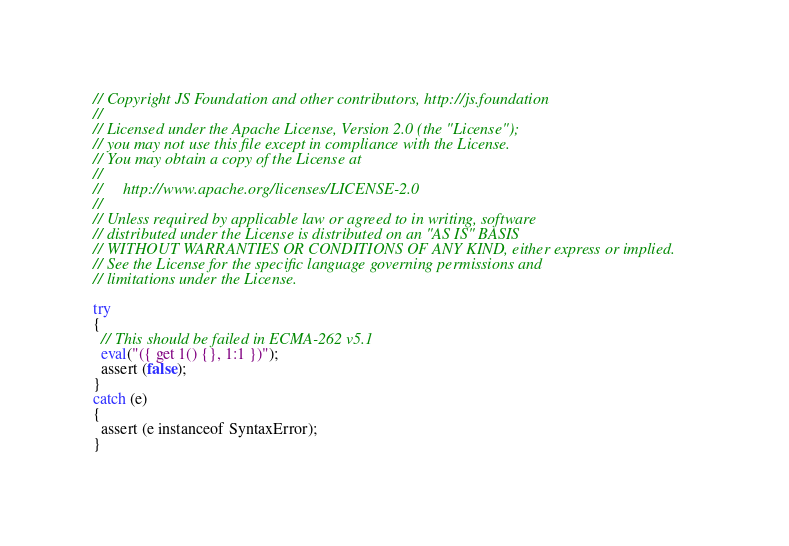Convert code to text. <code><loc_0><loc_0><loc_500><loc_500><_JavaScript_>// Copyright JS Foundation and other contributors, http://js.foundation
//
// Licensed under the Apache License, Version 2.0 (the "License");
// you may not use this file except in compliance with the License.
// You may obtain a copy of the License at
//
//     http://www.apache.org/licenses/LICENSE-2.0
//
// Unless required by applicable law or agreed to in writing, software
// distributed under the License is distributed on an "AS IS" BASIS
// WITHOUT WARRANTIES OR CONDITIONS OF ANY KIND, either express or implied.
// See the License for the specific language governing permissions and
// limitations under the License.

try
{
  // This should be failed in ECMA-262 v5.1
  eval("({ get 1() {}, 1:1 })");
  assert (false);
}
catch (e)
{
  assert (e instanceof SyntaxError);
}
</code> 